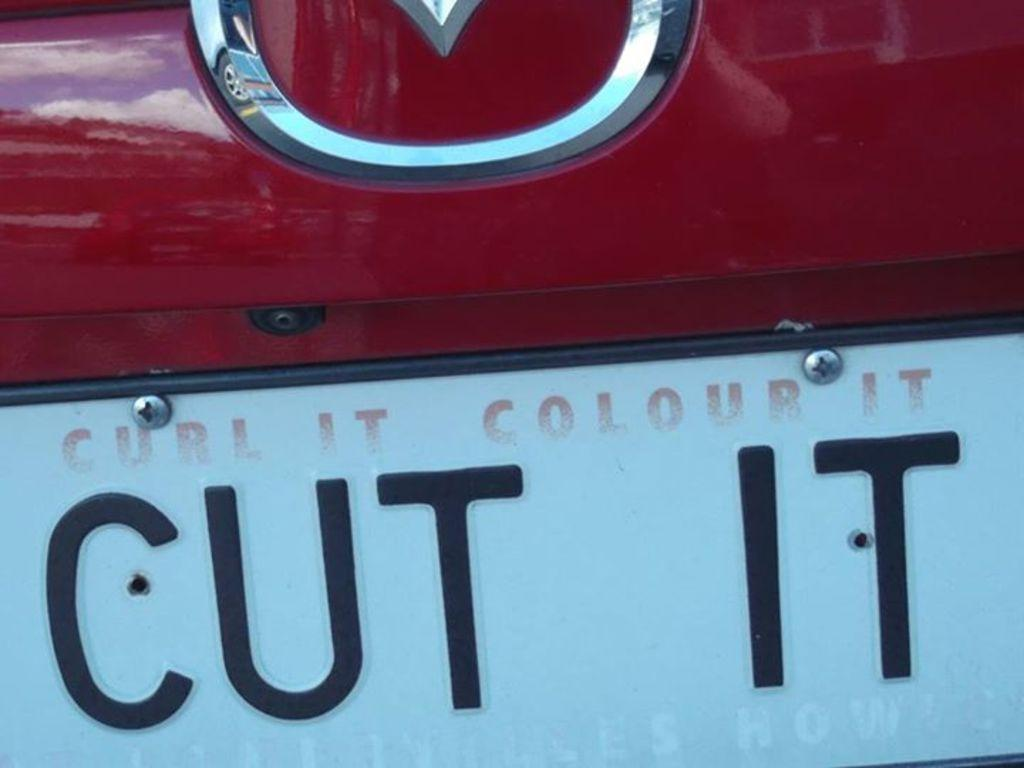Provide a one-sentence caption for the provided image. A vehicle's license plate consists of a stern order to "Cut It". 